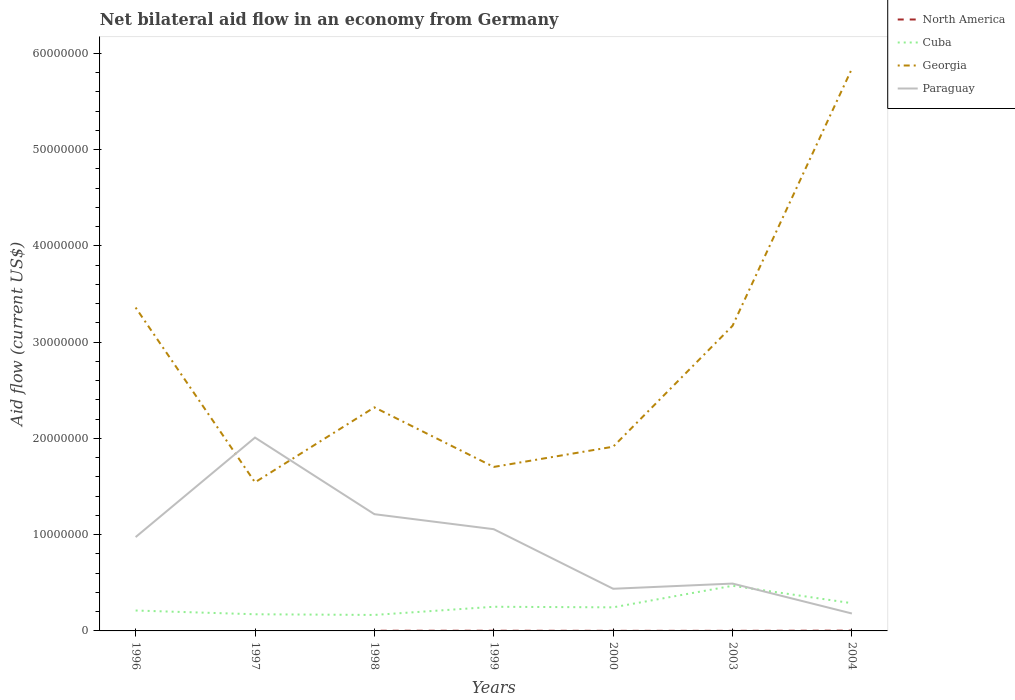Across all years, what is the maximum net bilateral aid flow in Cuba?
Ensure brevity in your answer.  1.66e+06. What is the total net bilateral aid flow in Paraguay in the graph?
Offer a terse response. 1.57e+07. What is the difference between the highest and the second highest net bilateral aid flow in Georgia?
Your answer should be compact. 4.30e+07. What is the difference between the highest and the lowest net bilateral aid flow in Cuba?
Provide a short and direct response. 2. How many lines are there?
Give a very brief answer. 4. How many years are there in the graph?
Provide a succinct answer. 7. Are the values on the major ticks of Y-axis written in scientific E-notation?
Provide a succinct answer. No. Where does the legend appear in the graph?
Provide a succinct answer. Top right. How many legend labels are there?
Your answer should be compact. 4. What is the title of the graph?
Your response must be concise. Net bilateral aid flow in an economy from Germany. Does "Iceland" appear as one of the legend labels in the graph?
Give a very brief answer. No. What is the label or title of the Y-axis?
Give a very brief answer. Aid flow (current US$). What is the Aid flow (current US$) in North America in 1996?
Your answer should be very brief. 0. What is the Aid flow (current US$) of Cuba in 1996?
Provide a succinct answer. 2.12e+06. What is the Aid flow (current US$) in Georgia in 1996?
Your response must be concise. 3.36e+07. What is the Aid flow (current US$) in Paraguay in 1996?
Ensure brevity in your answer.  9.75e+06. What is the Aid flow (current US$) in Cuba in 1997?
Provide a succinct answer. 1.73e+06. What is the Aid flow (current US$) of Georgia in 1997?
Keep it short and to the point. 1.54e+07. What is the Aid flow (current US$) of Paraguay in 1997?
Provide a short and direct response. 2.01e+07. What is the Aid flow (current US$) of North America in 1998?
Your answer should be very brief. 2.00e+04. What is the Aid flow (current US$) of Cuba in 1998?
Keep it short and to the point. 1.66e+06. What is the Aid flow (current US$) in Georgia in 1998?
Offer a very short reply. 2.32e+07. What is the Aid flow (current US$) of Paraguay in 1998?
Give a very brief answer. 1.21e+07. What is the Aid flow (current US$) in Cuba in 1999?
Your response must be concise. 2.51e+06. What is the Aid flow (current US$) of Georgia in 1999?
Your answer should be compact. 1.70e+07. What is the Aid flow (current US$) in Paraguay in 1999?
Make the answer very short. 1.06e+07. What is the Aid flow (current US$) of North America in 2000?
Your response must be concise. 10000. What is the Aid flow (current US$) in Cuba in 2000?
Ensure brevity in your answer.  2.45e+06. What is the Aid flow (current US$) in Georgia in 2000?
Provide a short and direct response. 1.91e+07. What is the Aid flow (current US$) of Paraguay in 2000?
Ensure brevity in your answer.  4.38e+06. What is the Aid flow (current US$) in North America in 2003?
Provide a short and direct response. 10000. What is the Aid flow (current US$) in Cuba in 2003?
Keep it short and to the point. 4.69e+06. What is the Aid flow (current US$) in Georgia in 2003?
Offer a very short reply. 3.17e+07. What is the Aid flow (current US$) in Paraguay in 2003?
Make the answer very short. 4.92e+06. What is the Aid flow (current US$) in North America in 2004?
Keep it short and to the point. 3.00e+04. What is the Aid flow (current US$) of Cuba in 2004?
Your answer should be compact. 2.88e+06. What is the Aid flow (current US$) in Georgia in 2004?
Provide a succinct answer. 5.84e+07. What is the Aid flow (current US$) in Paraguay in 2004?
Your answer should be compact. 1.81e+06. Across all years, what is the maximum Aid flow (current US$) of North America?
Give a very brief answer. 3.00e+04. Across all years, what is the maximum Aid flow (current US$) in Cuba?
Your answer should be compact. 4.69e+06. Across all years, what is the maximum Aid flow (current US$) of Georgia?
Offer a terse response. 5.84e+07. Across all years, what is the maximum Aid flow (current US$) in Paraguay?
Your answer should be very brief. 2.01e+07. Across all years, what is the minimum Aid flow (current US$) in North America?
Your answer should be compact. 0. Across all years, what is the minimum Aid flow (current US$) in Cuba?
Keep it short and to the point. 1.66e+06. Across all years, what is the minimum Aid flow (current US$) of Georgia?
Give a very brief answer. 1.54e+07. Across all years, what is the minimum Aid flow (current US$) in Paraguay?
Provide a short and direct response. 1.81e+06. What is the total Aid flow (current US$) of North America in the graph?
Offer a terse response. 9.00e+04. What is the total Aid flow (current US$) in Cuba in the graph?
Your answer should be compact. 1.80e+07. What is the total Aid flow (current US$) of Georgia in the graph?
Ensure brevity in your answer.  1.99e+08. What is the total Aid flow (current US$) in Paraguay in the graph?
Offer a terse response. 6.36e+07. What is the difference between the Aid flow (current US$) of Georgia in 1996 and that in 1997?
Your answer should be very brief. 1.82e+07. What is the difference between the Aid flow (current US$) in Paraguay in 1996 and that in 1997?
Keep it short and to the point. -1.03e+07. What is the difference between the Aid flow (current US$) of Cuba in 1996 and that in 1998?
Your answer should be compact. 4.60e+05. What is the difference between the Aid flow (current US$) of Georgia in 1996 and that in 1998?
Offer a very short reply. 1.04e+07. What is the difference between the Aid flow (current US$) in Paraguay in 1996 and that in 1998?
Your answer should be very brief. -2.38e+06. What is the difference between the Aid flow (current US$) of Cuba in 1996 and that in 1999?
Your answer should be very brief. -3.90e+05. What is the difference between the Aid flow (current US$) of Georgia in 1996 and that in 1999?
Provide a short and direct response. 1.66e+07. What is the difference between the Aid flow (current US$) in Paraguay in 1996 and that in 1999?
Offer a terse response. -8.20e+05. What is the difference between the Aid flow (current US$) in Cuba in 1996 and that in 2000?
Your response must be concise. -3.30e+05. What is the difference between the Aid flow (current US$) in Georgia in 1996 and that in 2000?
Offer a very short reply. 1.45e+07. What is the difference between the Aid flow (current US$) of Paraguay in 1996 and that in 2000?
Your response must be concise. 5.37e+06. What is the difference between the Aid flow (current US$) in Cuba in 1996 and that in 2003?
Give a very brief answer. -2.57e+06. What is the difference between the Aid flow (current US$) in Georgia in 1996 and that in 2003?
Provide a short and direct response. 1.90e+06. What is the difference between the Aid flow (current US$) in Paraguay in 1996 and that in 2003?
Provide a short and direct response. 4.83e+06. What is the difference between the Aid flow (current US$) of Cuba in 1996 and that in 2004?
Ensure brevity in your answer.  -7.60e+05. What is the difference between the Aid flow (current US$) in Georgia in 1996 and that in 2004?
Your answer should be very brief. -2.48e+07. What is the difference between the Aid flow (current US$) of Paraguay in 1996 and that in 2004?
Provide a short and direct response. 7.94e+06. What is the difference between the Aid flow (current US$) in Georgia in 1997 and that in 1998?
Your response must be concise. -7.79e+06. What is the difference between the Aid flow (current US$) in Paraguay in 1997 and that in 1998?
Offer a very short reply. 7.96e+06. What is the difference between the Aid flow (current US$) in Cuba in 1997 and that in 1999?
Your response must be concise. -7.80e+05. What is the difference between the Aid flow (current US$) in Georgia in 1997 and that in 1999?
Provide a succinct answer. -1.60e+06. What is the difference between the Aid flow (current US$) of Paraguay in 1997 and that in 1999?
Offer a very short reply. 9.52e+06. What is the difference between the Aid flow (current US$) in Cuba in 1997 and that in 2000?
Keep it short and to the point. -7.20e+05. What is the difference between the Aid flow (current US$) in Georgia in 1997 and that in 2000?
Make the answer very short. -3.70e+06. What is the difference between the Aid flow (current US$) of Paraguay in 1997 and that in 2000?
Provide a succinct answer. 1.57e+07. What is the difference between the Aid flow (current US$) of Cuba in 1997 and that in 2003?
Offer a very short reply. -2.96e+06. What is the difference between the Aid flow (current US$) in Georgia in 1997 and that in 2003?
Keep it short and to the point. -1.63e+07. What is the difference between the Aid flow (current US$) of Paraguay in 1997 and that in 2003?
Provide a short and direct response. 1.52e+07. What is the difference between the Aid flow (current US$) in Cuba in 1997 and that in 2004?
Your response must be concise. -1.15e+06. What is the difference between the Aid flow (current US$) in Georgia in 1997 and that in 2004?
Keep it short and to the point. -4.30e+07. What is the difference between the Aid flow (current US$) in Paraguay in 1997 and that in 2004?
Give a very brief answer. 1.83e+07. What is the difference between the Aid flow (current US$) of Cuba in 1998 and that in 1999?
Give a very brief answer. -8.50e+05. What is the difference between the Aid flow (current US$) of Georgia in 1998 and that in 1999?
Provide a short and direct response. 6.19e+06. What is the difference between the Aid flow (current US$) in Paraguay in 1998 and that in 1999?
Your answer should be very brief. 1.56e+06. What is the difference between the Aid flow (current US$) of Cuba in 1998 and that in 2000?
Provide a short and direct response. -7.90e+05. What is the difference between the Aid flow (current US$) in Georgia in 1998 and that in 2000?
Your response must be concise. 4.09e+06. What is the difference between the Aid flow (current US$) in Paraguay in 1998 and that in 2000?
Make the answer very short. 7.75e+06. What is the difference between the Aid flow (current US$) in Cuba in 1998 and that in 2003?
Give a very brief answer. -3.03e+06. What is the difference between the Aid flow (current US$) in Georgia in 1998 and that in 2003?
Offer a very short reply. -8.47e+06. What is the difference between the Aid flow (current US$) of Paraguay in 1998 and that in 2003?
Provide a short and direct response. 7.21e+06. What is the difference between the Aid flow (current US$) in Cuba in 1998 and that in 2004?
Offer a very short reply. -1.22e+06. What is the difference between the Aid flow (current US$) in Georgia in 1998 and that in 2004?
Provide a short and direct response. -3.52e+07. What is the difference between the Aid flow (current US$) of Paraguay in 1998 and that in 2004?
Make the answer very short. 1.03e+07. What is the difference between the Aid flow (current US$) in North America in 1999 and that in 2000?
Your answer should be very brief. 10000. What is the difference between the Aid flow (current US$) in Georgia in 1999 and that in 2000?
Make the answer very short. -2.10e+06. What is the difference between the Aid flow (current US$) of Paraguay in 1999 and that in 2000?
Your response must be concise. 6.19e+06. What is the difference between the Aid flow (current US$) of North America in 1999 and that in 2003?
Your answer should be very brief. 10000. What is the difference between the Aid flow (current US$) in Cuba in 1999 and that in 2003?
Offer a terse response. -2.18e+06. What is the difference between the Aid flow (current US$) of Georgia in 1999 and that in 2003?
Provide a succinct answer. -1.47e+07. What is the difference between the Aid flow (current US$) of Paraguay in 1999 and that in 2003?
Your answer should be very brief. 5.65e+06. What is the difference between the Aid flow (current US$) in North America in 1999 and that in 2004?
Keep it short and to the point. -10000. What is the difference between the Aid flow (current US$) in Cuba in 1999 and that in 2004?
Provide a short and direct response. -3.70e+05. What is the difference between the Aid flow (current US$) in Georgia in 1999 and that in 2004?
Provide a succinct answer. -4.14e+07. What is the difference between the Aid flow (current US$) in Paraguay in 1999 and that in 2004?
Your response must be concise. 8.76e+06. What is the difference between the Aid flow (current US$) in North America in 2000 and that in 2003?
Give a very brief answer. 0. What is the difference between the Aid flow (current US$) of Cuba in 2000 and that in 2003?
Your answer should be compact. -2.24e+06. What is the difference between the Aid flow (current US$) of Georgia in 2000 and that in 2003?
Your answer should be very brief. -1.26e+07. What is the difference between the Aid flow (current US$) of Paraguay in 2000 and that in 2003?
Your answer should be very brief. -5.40e+05. What is the difference between the Aid flow (current US$) of North America in 2000 and that in 2004?
Provide a short and direct response. -2.00e+04. What is the difference between the Aid flow (current US$) of Cuba in 2000 and that in 2004?
Provide a succinct answer. -4.30e+05. What is the difference between the Aid flow (current US$) in Georgia in 2000 and that in 2004?
Give a very brief answer. -3.93e+07. What is the difference between the Aid flow (current US$) in Paraguay in 2000 and that in 2004?
Offer a very short reply. 2.57e+06. What is the difference between the Aid flow (current US$) of North America in 2003 and that in 2004?
Offer a terse response. -2.00e+04. What is the difference between the Aid flow (current US$) in Cuba in 2003 and that in 2004?
Make the answer very short. 1.81e+06. What is the difference between the Aid flow (current US$) of Georgia in 2003 and that in 2004?
Your response must be concise. -2.67e+07. What is the difference between the Aid flow (current US$) of Paraguay in 2003 and that in 2004?
Provide a short and direct response. 3.11e+06. What is the difference between the Aid flow (current US$) of Cuba in 1996 and the Aid flow (current US$) of Georgia in 1997?
Provide a short and direct response. -1.33e+07. What is the difference between the Aid flow (current US$) in Cuba in 1996 and the Aid flow (current US$) in Paraguay in 1997?
Provide a succinct answer. -1.80e+07. What is the difference between the Aid flow (current US$) of Georgia in 1996 and the Aid flow (current US$) of Paraguay in 1997?
Keep it short and to the point. 1.35e+07. What is the difference between the Aid flow (current US$) in Cuba in 1996 and the Aid flow (current US$) in Georgia in 1998?
Ensure brevity in your answer.  -2.11e+07. What is the difference between the Aid flow (current US$) in Cuba in 1996 and the Aid flow (current US$) in Paraguay in 1998?
Make the answer very short. -1.00e+07. What is the difference between the Aid flow (current US$) of Georgia in 1996 and the Aid flow (current US$) of Paraguay in 1998?
Provide a succinct answer. 2.15e+07. What is the difference between the Aid flow (current US$) of Cuba in 1996 and the Aid flow (current US$) of Georgia in 1999?
Offer a very short reply. -1.49e+07. What is the difference between the Aid flow (current US$) of Cuba in 1996 and the Aid flow (current US$) of Paraguay in 1999?
Offer a terse response. -8.45e+06. What is the difference between the Aid flow (current US$) in Georgia in 1996 and the Aid flow (current US$) in Paraguay in 1999?
Your answer should be compact. 2.30e+07. What is the difference between the Aid flow (current US$) in Cuba in 1996 and the Aid flow (current US$) in Georgia in 2000?
Provide a short and direct response. -1.70e+07. What is the difference between the Aid flow (current US$) in Cuba in 1996 and the Aid flow (current US$) in Paraguay in 2000?
Offer a terse response. -2.26e+06. What is the difference between the Aid flow (current US$) in Georgia in 1996 and the Aid flow (current US$) in Paraguay in 2000?
Offer a very short reply. 2.92e+07. What is the difference between the Aid flow (current US$) of Cuba in 1996 and the Aid flow (current US$) of Georgia in 2003?
Your answer should be compact. -2.96e+07. What is the difference between the Aid flow (current US$) in Cuba in 1996 and the Aid flow (current US$) in Paraguay in 2003?
Offer a terse response. -2.80e+06. What is the difference between the Aid flow (current US$) of Georgia in 1996 and the Aid flow (current US$) of Paraguay in 2003?
Give a very brief answer. 2.87e+07. What is the difference between the Aid flow (current US$) in Cuba in 1996 and the Aid flow (current US$) in Georgia in 2004?
Your answer should be compact. -5.63e+07. What is the difference between the Aid flow (current US$) in Cuba in 1996 and the Aid flow (current US$) in Paraguay in 2004?
Give a very brief answer. 3.10e+05. What is the difference between the Aid flow (current US$) in Georgia in 1996 and the Aid flow (current US$) in Paraguay in 2004?
Your response must be concise. 3.18e+07. What is the difference between the Aid flow (current US$) of Cuba in 1997 and the Aid flow (current US$) of Georgia in 1998?
Ensure brevity in your answer.  -2.15e+07. What is the difference between the Aid flow (current US$) of Cuba in 1997 and the Aid flow (current US$) of Paraguay in 1998?
Your answer should be compact. -1.04e+07. What is the difference between the Aid flow (current US$) of Georgia in 1997 and the Aid flow (current US$) of Paraguay in 1998?
Provide a succinct answer. 3.31e+06. What is the difference between the Aid flow (current US$) of Cuba in 1997 and the Aid flow (current US$) of Georgia in 1999?
Give a very brief answer. -1.53e+07. What is the difference between the Aid flow (current US$) in Cuba in 1997 and the Aid flow (current US$) in Paraguay in 1999?
Provide a succinct answer. -8.84e+06. What is the difference between the Aid flow (current US$) in Georgia in 1997 and the Aid flow (current US$) in Paraguay in 1999?
Make the answer very short. 4.87e+06. What is the difference between the Aid flow (current US$) in Cuba in 1997 and the Aid flow (current US$) in Georgia in 2000?
Your answer should be compact. -1.74e+07. What is the difference between the Aid flow (current US$) of Cuba in 1997 and the Aid flow (current US$) of Paraguay in 2000?
Provide a short and direct response. -2.65e+06. What is the difference between the Aid flow (current US$) of Georgia in 1997 and the Aid flow (current US$) of Paraguay in 2000?
Provide a succinct answer. 1.11e+07. What is the difference between the Aid flow (current US$) in Cuba in 1997 and the Aid flow (current US$) in Georgia in 2003?
Your response must be concise. -3.00e+07. What is the difference between the Aid flow (current US$) in Cuba in 1997 and the Aid flow (current US$) in Paraguay in 2003?
Offer a very short reply. -3.19e+06. What is the difference between the Aid flow (current US$) of Georgia in 1997 and the Aid flow (current US$) of Paraguay in 2003?
Your answer should be compact. 1.05e+07. What is the difference between the Aid flow (current US$) of Cuba in 1997 and the Aid flow (current US$) of Georgia in 2004?
Your answer should be very brief. -5.67e+07. What is the difference between the Aid flow (current US$) of Georgia in 1997 and the Aid flow (current US$) of Paraguay in 2004?
Your answer should be very brief. 1.36e+07. What is the difference between the Aid flow (current US$) of North America in 1998 and the Aid flow (current US$) of Cuba in 1999?
Your answer should be compact. -2.49e+06. What is the difference between the Aid flow (current US$) in North America in 1998 and the Aid flow (current US$) in Georgia in 1999?
Offer a terse response. -1.70e+07. What is the difference between the Aid flow (current US$) in North America in 1998 and the Aid flow (current US$) in Paraguay in 1999?
Your response must be concise. -1.06e+07. What is the difference between the Aid flow (current US$) in Cuba in 1998 and the Aid flow (current US$) in Georgia in 1999?
Keep it short and to the point. -1.54e+07. What is the difference between the Aid flow (current US$) of Cuba in 1998 and the Aid flow (current US$) of Paraguay in 1999?
Keep it short and to the point. -8.91e+06. What is the difference between the Aid flow (current US$) in Georgia in 1998 and the Aid flow (current US$) in Paraguay in 1999?
Provide a short and direct response. 1.27e+07. What is the difference between the Aid flow (current US$) in North America in 1998 and the Aid flow (current US$) in Cuba in 2000?
Ensure brevity in your answer.  -2.43e+06. What is the difference between the Aid flow (current US$) of North America in 1998 and the Aid flow (current US$) of Georgia in 2000?
Your response must be concise. -1.91e+07. What is the difference between the Aid flow (current US$) in North America in 1998 and the Aid flow (current US$) in Paraguay in 2000?
Keep it short and to the point. -4.36e+06. What is the difference between the Aid flow (current US$) in Cuba in 1998 and the Aid flow (current US$) in Georgia in 2000?
Your response must be concise. -1.75e+07. What is the difference between the Aid flow (current US$) in Cuba in 1998 and the Aid flow (current US$) in Paraguay in 2000?
Ensure brevity in your answer.  -2.72e+06. What is the difference between the Aid flow (current US$) in Georgia in 1998 and the Aid flow (current US$) in Paraguay in 2000?
Offer a terse response. 1.88e+07. What is the difference between the Aid flow (current US$) in North America in 1998 and the Aid flow (current US$) in Cuba in 2003?
Your response must be concise. -4.67e+06. What is the difference between the Aid flow (current US$) of North America in 1998 and the Aid flow (current US$) of Georgia in 2003?
Your answer should be very brief. -3.17e+07. What is the difference between the Aid flow (current US$) in North America in 1998 and the Aid flow (current US$) in Paraguay in 2003?
Make the answer very short. -4.90e+06. What is the difference between the Aid flow (current US$) of Cuba in 1998 and the Aid flow (current US$) of Georgia in 2003?
Provide a succinct answer. -3.00e+07. What is the difference between the Aid flow (current US$) of Cuba in 1998 and the Aid flow (current US$) of Paraguay in 2003?
Ensure brevity in your answer.  -3.26e+06. What is the difference between the Aid flow (current US$) of Georgia in 1998 and the Aid flow (current US$) of Paraguay in 2003?
Keep it short and to the point. 1.83e+07. What is the difference between the Aid flow (current US$) in North America in 1998 and the Aid flow (current US$) in Cuba in 2004?
Your response must be concise. -2.86e+06. What is the difference between the Aid flow (current US$) of North America in 1998 and the Aid flow (current US$) of Georgia in 2004?
Your response must be concise. -5.84e+07. What is the difference between the Aid flow (current US$) of North America in 1998 and the Aid flow (current US$) of Paraguay in 2004?
Give a very brief answer. -1.79e+06. What is the difference between the Aid flow (current US$) in Cuba in 1998 and the Aid flow (current US$) in Georgia in 2004?
Provide a succinct answer. -5.68e+07. What is the difference between the Aid flow (current US$) of Georgia in 1998 and the Aid flow (current US$) of Paraguay in 2004?
Your answer should be very brief. 2.14e+07. What is the difference between the Aid flow (current US$) in North America in 1999 and the Aid flow (current US$) in Cuba in 2000?
Give a very brief answer. -2.43e+06. What is the difference between the Aid flow (current US$) of North America in 1999 and the Aid flow (current US$) of Georgia in 2000?
Ensure brevity in your answer.  -1.91e+07. What is the difference between the Aid flow (current US$) of North America in 1999 and the Aid flow (current US$) of Paraguay in 2000?
Offer a terse response. -4.36e+06. What is the difference between the Aid flow (current US$) in Cuba in 1999 and the Aid flow (current US$) in Georgia in 2000?
Provide a succinct answer. -1.66e+07. What is the difference between the Aid flow (current US$) in Cuba in 1999 and the Aid flow (current US$) in Paraguay in 2000?
Give a very brief answer. -1.87e+06. What is the difference between the Aid flow (current US$) of Georgia in 1999 and the Aid flow (current US$) of Paraguay in 2000?
Ensure brevity in your answer.  1.27e+07. What is the difference between the Aid flow (current US$) of North America in 1999 and the Aid flow (current US$) of Cuba in 2003?
Give a very brief answer. -4.67e+06. What is the difference between the Aid flow (current US$) of North America in 1999 and the Aid flow (current US$) of Georgia in 2003?
Provide a succinct answer. -3.17e+07. What is the difference between the Aid flow (current US$) of North America in 1999 and the Aid flow (current US$) of Paraguay in 2003?
Provide a succinct answer. -4.90e+06. What is the difference between the Aid flow (current US$) of Cuba in 1999 and the Aid flow (current US$) of Georgia in 2003?
Provide a succinct answer. -2.92e+07. What is the difference between the Aid flow (current US$) in Cuba in 1999 and the Aid flow (current US$) in Paraguay in 2003?
Offer a terse response. -2.41e+06. What is the difference between the Aid flow (current US$) of Georgia in 1999 and the Aid flow (current US$) of Paraguay in 2003?
Ensure brevity in your answer.  1.21e+07. What is the difference between the Aid flow (current US$) of North America in 1999 and the Aid flow (current US$) of Cuba in 2004?
Provide a succinct answer. -2.86e+06. What is the difference between the Aid flow (current US$) of North America in 1999 and the Aid flow (current US$) of Georgia in 2004?
Your answer should be compact. -5.84e+07. What is the difference between the Aid flow (current US$) in North America in 1999 and the Aid flow (current US$) in Paraguay in 2004?
Your answer should be very brief. -1.79e+06. What is the difference between the Aid flow (current US$) of Cuba in 1999 and the Aid flow (current US$) of Georgia in 2004?
Your response must be concise. -5.59e+07. What is the difference between the Aid flow (current US$) of Georgia in 1999 and the Aid flow (current US$) of Paraguay in 2004?
Your answer should be very brief. 1.52e+07. What is the difference between the Aid flow (current US$) of North America in 2000 and the Aid flow (current US$) of Cuba in 2003?
Offer a terse response. -4.68e+06. What is the difference between the Aid flow (current US$) in North America in 2000 and the Aid flow (current US$) in Georgia in 2003?
Your answer should be compact. -3.17e+07. What is the difference between the Aid flow (current US$) in North America in 2000 and the Aid flow (current US$) in Paraguay in 2003?
Your answer should be very brief. -4.91e+06. What is the difference between the Aid flow (current US$) in Cuba in 2000 and the Aid flow (current US$) in Georgia in 2003?
Your response must be concise. -2.92e+07. What is the difference between the Aid flow (current US$) in Cuba in 2000 and the Aid flow (current US$) in Paraguay in 2003?
Offer a terse response. -2.47e+06. What is the difference between the Aid flow (current US$) in Georgia in 2000 and the Aid flow (current US$) in Paraguay in 2003?
Your answer should be compact. 1.42e+07. What is the difference between the Aid flow (current US$) of North America in 2000 and the Aid flow (current US$) of Cuba in 2004?
Give a very brief answer. -2.87e+06. What is the difference between the Aid flow (current US$) in North America in 2000 and the Aid flow (current US$) in Georgia in 2004?
Make the answer very short. -5.84e+07. What is the difference between the Aid flow (current US$) of North America in 2000 and the Aid flow (current US$) of Paraguay in 2004?
Your answer should be very brief. -1.80e+06. What is the difference between the Aid flow (current US$) of Cuba in 2000 and the Aid flow (current US$) of Georgia in 2004?
Offer a very short reply. -5.60e+07. What is the difference between the Aid flow (current US$) in Cuba in 2000 and the Aid flow (current US$) in Paraguay in 2004?
Keep it short and to the point. 6.40e+05. What is the difference between the Aid flow (current US$) in Georgia in 2000 and the Aid flow (current US$) in Paraguay in 2004?
Give a very brief answer. 1.73e+07. What is the difference between the Aid flow (current US$) in North America in 2003 and the Aid flow (current US$) in Cuba in 2004?
Ensure brevity in your answer.  -2.87e+06. What is the difference between the Aid flow (current US$) of North America in 2003 and the Aid flow (current US$) of Georgia in 2004?
Your response must be concise. -5.84e+07. What is the difference between the Aid flow (current US$) in North America in 2003 and the Aid flow (current US$) in Paraguay in 2004?
Make the answer very short. -1.80e+06. What is the difference between the Aid flow (current US$) in Cuba in 2003 and the Aid flow (current US$) in Georgia in 2004?
Your response must be concise. -5.37e+07. What is the difference between the Aid flow (current US$) of Cuba in 2003 and the Aid flow (current US$) of Paraguay in 2004?
Give a very brief answer. 2.88e+06. What is the difference between the Aid flow (current US$) of Georgia in 2003 and the Aid flow (current US$) of Paraguay in 2004?
Your answer should be very brief. 2.99e+07. What is the average Aid flow (current US$) in North America per year?
Your answer should be compact. 1.29e+04. What is the average Aid flow (current US$) in Cuba per year?
Offer a terse response. 2.58e+06. What is the average Aid flow (current US$) of Georgia per year?
Keep it short and to the point. 2.84e+07. What is the average Aid flow (current US$) of Paraguay per year?
Give a very brief answer. 9.09e+06. In the year 1996, what is the difference between the Aid flow (current US$) in Cuba and Aid flow (current US$) in Georgia?
Offer a terse response. -3.15e+07. In the year 1996, what is the difference between the Aid flow (current US$) in Cuba and Aid flow (current US$) in Paraguay?
Your answer should be compact. -7.63e+06. In the year 1996, what is the difference between the Aid flow (current US$) in Georgia and Aid flow (current US$) in Paraguay?
Your response must be concise. 2.38e+07. In the year 1997, what is the difference between the Aid flow (current US$) of Cuba and Aid flow (current US$) of Georgia?
Provide a succinct answer. -1.37e+07. In the year 1997, what is the difference between the Aid flow (current US$) of Cuba and Aid flow (current US$) of Paraguay?
Ensure brevity in your answer.  -1.84e+07. In the year 1997, what is the difference between the Aid flow (current US$) in Georgia and Aid flow (current US$) in Paraguay?
Offer a very short reply. -4.65e+06. In the year 1998, what is the difference between the Aid flow (current US$) in North America and Aid flow (current US$) in Cuba?
Your answer should be very brief. -1.64e+06. In the year 1998, what is the difference between the Aid flow (current US$) in North America and Aid flow (current US$) in Georgia?
Give a very brief answer. -2.32e+07. In the year 1998, what is the difference between the Aid flow (current US$) of North America and Aid flow (current US$) of Paraguay?
Provide a succinct answer. -1.21e+07. In the year 1998, what is the difference between the Aid flow (current US$) in Cuba and Aid flow (current US$) in Georgia?
Offer a terse response. -2.16e+07. In the year 1998, what is the difference between the Aid flow (current US$) of Cuba and Aid flow (current US$) of Paraguay?
Keep it short and to the point. -1.05e+07. In the year 1998, what is the difference between the Aid flow (current US$) in Georgia and Aid flow (current US$) in Paraguay?
Ensure brevity in your answer.  1.11e+07. In the year 1999, what is the difference between the Aid flow (current US$) of North America and Aid flow (current US$) of Cuba?
Your answer should be very brief. -2.49e+06. In the year 1999, what is the difference between the Aid flow (current US$) in North America and Aid flow (current US$) in Georgia?
Your answer should be compact. -1.70e+07. In the year 1999, what is the difference between the Aid flow (current US$) of North America and Aid flow (current US$) of Paraguay?
Offer a very short reply. -1.06e+07. In the year 1999, what is the difference between the Aid flow (current US$) of Cuba and Aid flow (current US$) of Georgia?
Ensure brevity in your answer.  -1.45e+07. In the year 1999, what is the difference between the Aid flow (current US$) in Cuba and Aid flow (current US$) in Paraguay?
Provide a short and direct response. -8.06e+06. In the year 1999, what is the difference between the Aid flow (current US$) of Georgia and Aid flow (current US$) of Paraguay?
Offer a terse response. 6.47e+06. In the year 2000, what is the difference between the Aid flow (current US$) of North America and Aid flow (current US$) of Cuba?
Your answer should be compact. -2.44e+06. In the year 2000, what is the difference between the Aid flow (current US$) of North America and Aid flow (current US$) of Georgia?
Your answer should be compact. -1.91e+07. In the year 2000, what is the difference between the Aid flow (current US$) of North America and Aid flow (current US$) of Paraguay?
Ensure brevity in your answer.  -4.37e+06. In the year 2000, what is the difference between the Aid flow (current US$) of Cuba and Aid flow (current US$) of Georgia?
Keep it short and to the point. -1.67e+07. In the year 2000, what is the difference between the Aid flow (current US$) in Cuba and Aid flow (current US$) in Paraguay?
Give a very brief answer. -1.93e+06. In the year 2000, what is the difference between the Aid flow (current US$) of Georgia and Aid flow (current US$) of Paraguay?
Provide a succinct answer. 1.48e+07. In the year 2003, what is the difference between the Aid flow (current US$) of North America and Aid flow (current US$) of Cuba?
Ensure brevity in your answer.  -4.68e+06. In the year 2003, what is the difference between the Aid flow (current US$) in North America and Aid flow (current US$) in Georgia?
Make the answer very short. -3.17e+07. In the year 2003, what is the difference between the Aid flow (current US$) in North America and Aid flow (current US$) in Paraguay?
Give a very brief answer. -4.91e+06. In the year 2003, what is the difference between the Aid flow (current US$) in Cuba and Aid flow (current US$) in Georgia?
Your answer should be very brief. -2.70e+07. In the year 2003, what is the difference between the Aid flow (current US$) in Cuba and Aid flow (current US$) in Paraguay?
Give a very brief answer. -2.30e+05. In the year 2003, what is the difference between the Aid flow (current US$) in Georgia and Aid flow (current US$) in Paraguay?
Offer a terse response. 2.68e+07. In the year 2004, what is the difference between the Aid flow (current US$) in North America and Aid flow (current US$) in Cuba?
Your answer should be very brief. -2.85e+06. In the year 2004, what is the difference between the Aid flow (current US$) of North America and Aid flow (current US$) of Georgia?
Make the answer very short. -5.84e+07. In the year 2004, what is the difference between the Aid flow (current US$) of North America and Aid flow (current US$) of Paraguay?
Make the answer very short. -1.78e+06. In the year 2004, what is the difference between the Aid flow (current US$) of Cuba and Aid flow (current US$) of Georgia?
Offer a terse response. -5.55e+07. In the year 2004, what is the difference between the Aid flow (current US$) of Cuba and Aid flow (current US$) of Paraguay?
Ensure brevity in your answer.  1.07e+06. In the year 2004, what is the difference between the Aid flow (current US$) of Georgia and Aid flow (current US$) of Paraguay?
Provide a succinct answer. 5.66e+07. What is the ratio of the Aid flow (current US$) of Cuba in 1996 to that in 1997?
Keep it short and to the point. 1.23. What is the ratio of the Aid flow (current US$) in Georgia in 1996 to that in 1997?
Ensure brevity in your answer.  2.18. What is the ratio of the Aid flow (current US$) in Paraguay in 1996 to that in 1997?
Offer a terse response. 0.49. What is the ratio of the Aid flow (current US$) in Cuba in 1996 to that in 1998?
Keep it short and to the point. 1.28. What is the ratio of the Aid flow (current US$) of Georgia in 1996 to that in 1998?
Offer a very short reply. 1.45. What is the ratio of the Aid flow (current US$) of Paraguay in 1996 to that in 1998?
Your answer should be compact. 0.8. What is the ratio of the Aid flow (current US$) in Cuba in 1996 to that in 1999?
Keep it short and to the point. 0.84. What is the ratio of the Aid flow (current US$) of Georgia in 1996 to that in 1999?
Give a very brief answer. 1.97. What is the ratio of the Aid flow (current US$) in Paraguay in 1996 to that in 1999?
Offer a very short reply. 0.92. What is the ratio of the Aid flow (current US$) in Cuba in 1996 to that in 2000?
Keep it short and to the point. 0.87. What is the ratio of the Aid flow (current US$) of Georgia in 1996 to that in 2000?
Your answer should be very brief. 1.76. What is the ratio of the Aid flow (current US$) of Paraguay in 1996 to that in 2000?
Keep it short and to the point. 2.23. What is the ratio of the Aid flow (current US$) in Cuba in 1996 to that in 2003?
Provide a short and direct response. 0.45. What is the ratio of the Aid flow (current US$) in Georgia in 1996 to that in 2003?
Offer a terse response. 1.06. What is the ratio of the Aid flow (current US$) of Paraguay in 1996 to that in 2003?
Keep it short and to the point. 1.98. What is the ratio of the Aid flow (current US$) in Cuba in 1996 to that in 2004?
Make the answer very short. 0.74. What is the ratio of the Aid flow (current US$) of Georgia in 1996 to that in 2004?
Your answer should be very brief. 0.58. What is the ratio of the Aid flow (current US$) in Paraguay in 1996 to that in 2004?
Your response must be concise. 5.39. What is the ratio of the Aid flow (current US$) of Cuba in 1997 to that in 1998?
Make the answer very short. 1.04. What is the ratio of the Aid flow (current US$) in Georgia in 1997 to that in 1998?
Provide a succinct answer. 0.66. What is the ratio of the Aid flow (current US$) in Paraguay in 1997 to that in 1998?
Your answer should be very brief. 1.66. What is the ratio of the Aid flow (current US$) in Cuba in 1997 to that in 1999?
Ensure brevity in your answer.  0.69. What is the ratio of the Aid flow (current US$) in Georgia in 1997 to that in 1999?
Make the answer very short. 0.91. What is the ratio of the Aid flow (current US$) in Paraguay in 1997 to that in 1999?
Your answer should be very brief. 1.9. What is the ratio of the Aid flow (current US$) in Cuba in 1997 to that in 2000?
Your answer should be very brief. 0.71. What is the ratio of the Aid flow (current US$) in Georgia in 1997 to that in 2000?
Provide a succinct answer. 0.81. What is the ratio of the Aid flow (current US$) of Paraguay in 1997 to that in 2000?
Keep it short and to the point. 4.59. What is the ratio of the Aid flow (current US$) of Cuba in 1997 to that in 2003?
Your answer should be compact. 0.37. What is the ratio of the Aid flow (current US$) of Georgia in 1997 to that in 2003?
Give a very brief answer. 0.49. What is the ratio of the Aid flow (current US$) of Paraguay in 1997 to that in 2003?
Provide a short and direct response. 4.08. What is the ratio of the Aid flow (current US$) of Cuba in 1997 to that in 2004?
Offer a terse response. 0.6. What is the ratio of the Aid flow (current US$) of Georgia in 1997 to that in 2004?
Your answer should be very brief. 0.26. What is the ratio of the Aid flow (current US$) of Paraguay in 1997 to that in 2004?
Offer a terse response. 11.1. What is the ratio of the Aid flow (current US$) of Cuba in 1998 to that in 1999?
Your response must be concise. 0.66. What is the ratio of the Aid flow (current US$) of Georgia in 1998 to that in 1999?
Ensure brevity in your answer.  1.36. What is the ratio of the Aid flow (current US$) in Paraguay in 1998 to that in 1999?
Ensure brevity in your answer.  1.15. What is the ratio of the Aid flow (current US$) in North America in 1998 to that in 2000?
Provide a succinct answer. 2. What is the ratio of the Aid flow (current US$) of Cuba in 1998 to that in 2000?
Give a very brief answer. 0.68. What is the ratio of the Aid flow (current US$) in Georgia in 1998 to that in 2000?
Give a very brief answer. 1.21. What is the ratio of the Aid flow (current US$) of Paraguay in 1998 to that in 2000?
Ensure brevity in your answer.  2.77. What is the ratio of the Aid flow (current US$) in North America in 1998 to that in 2003?
Your response must be concise. 2. What is the ratio of the Aid flow (current US$) in Cuba in 1998 to that in 2003?
Provide a succinct answer. 0.35. What is the ratio of the Aid flow (current US$) in Georgia in 1998 to that in 2003?
Provide a short and direct response. 0.73. What is the ratio of the Aid flow (current US$) of Paraguay in 1998 to that in 2003?
Your answer should be very brief. 2.47. What is the ratio of the Aid flow (current US$) in Cuba in 1998 to that in 2004?
Keep it short and to the point. 0.58. What is the ratio of the Aid flow (current US$) of Georgia in 1998 to that in 2004?
Your answer should be compact. 0.4. What is the ratio of the Aid flow (current US$) in Paraguay in 1998 to that in 2004?
Your answer should be compact. 6.7. What is the ratio of the Aid flow (current US$) in Cuba in 1999 to that in 2000?
Offer a terse response. 1.02. What is the ratio of the Aid flow (current US$) of Georgia in 1999 to that in 2000?
Provide a short and direct response. 0.89. What is the ratio of the Aid flow (current US$) in Paraguay in 1999 to that in 2000?
Ensure brevity in your answer.  2.41. What is the ratio of the Aid flow (current US$) of Cuba in 1999 to that in 2003?
Your answer should be very brief. 0.54. What is the ratio of the Aid flow (current US$) in Georgia in 1999 to that in 2003?
Your response must be concise. 0.54. What is the ratio of the Aid flow (current US$) in Paraguay in 1999 to that in 2003?
Your answer should be compact. 2.15. What is the ratio of the Aid flow (current US$) in Cuba in 1999 to that in 2004?
Your response must be concise. 0.87. What is the ratio of the Aid flow (current US$) of Georgia in 1999 to that in 2004?
Keep it short and to the point. 0.29. What is the ratio of the Aid flow (current US$) in Paraguay in 1999 to that in 2004?
Keep it short and to the point. 5.84. What is the ratio of the Aid flow (current US$) in Cuba in 2000 to that in 2003?
Provide a succinct answer. 0.52. What is the ratio of the Aid flow (current US$) of Georgia in 2000 to that in 2003?
Ensure brevity in your answer.  0.6. What is the ratio of the Aid flow (current US$) in Paraguay in 2000 to that in 2003?
Ensure brevity in your answer.  0.89. What is the ratio of the Aid flow (current US$) in North America in 2000 to that in 2004?
Make the answer very short. 0.33. What is the ratio of the Aid flow (current US$) of Cuba in 2000 to that in 2004?
Your answer should be compact. 0.85. What is the ratio of the Aid flow (current US$) in Georgia in 2000 to that in 2004?
Offer a terse response. 0.33. What is the ratio of the Aid flow (current US$) in Paraguay in 2000 to that in 2004?
Offer a very short reply. 2.42. What is the ratio of the Aid flow (current US$) of North America in 2003 to that in 2004?
Offer a terse response. 0.33. What is the ratio of the Aid flow (current US$) in Cuba in 2003 to that in 2004?
Your answer should be very brief. 1.63. What is the ratio of the Aid flow (current US$) in Georgia in 2003 to that in 2004?
Ensure brevity in your answer.  0.54. What is the ratio of the Aid flow (current US$) in Paraguay in 2003 to that in 2004?
Make the answer very short. 2.72. What is the difference between the highest and the second highest Aid flow (current US$) in Cuba?
Make the answer very short. 1.81e+06. What is the difference between the highest and the second highest Aid flow (current US$) of Georgia?
Your answer should be very brief. 2.48e+07. What is the difference between the highest and the second highest Aid flow (current US$) of Paraguay?
Make the answer very short. 7.96e+06. What is the difference between the highest and the lowest Aid flow (current US$) of North America?
Provide a short and direct response. 3.00e+04. What is the difference between the highest and the lowest Aid flow (current US$) in Cuba?
Give a very brief answer. 3.03e+06. What is the difference between the highest and the lowest Aid flow (current US$) of Georgia?
Your answer should be very brief. 4.30e+07. What is the difference between the highest and the lowest Aid flow (current US$) of Paraguay?
Offer a very short reply. 1.83e+07. 